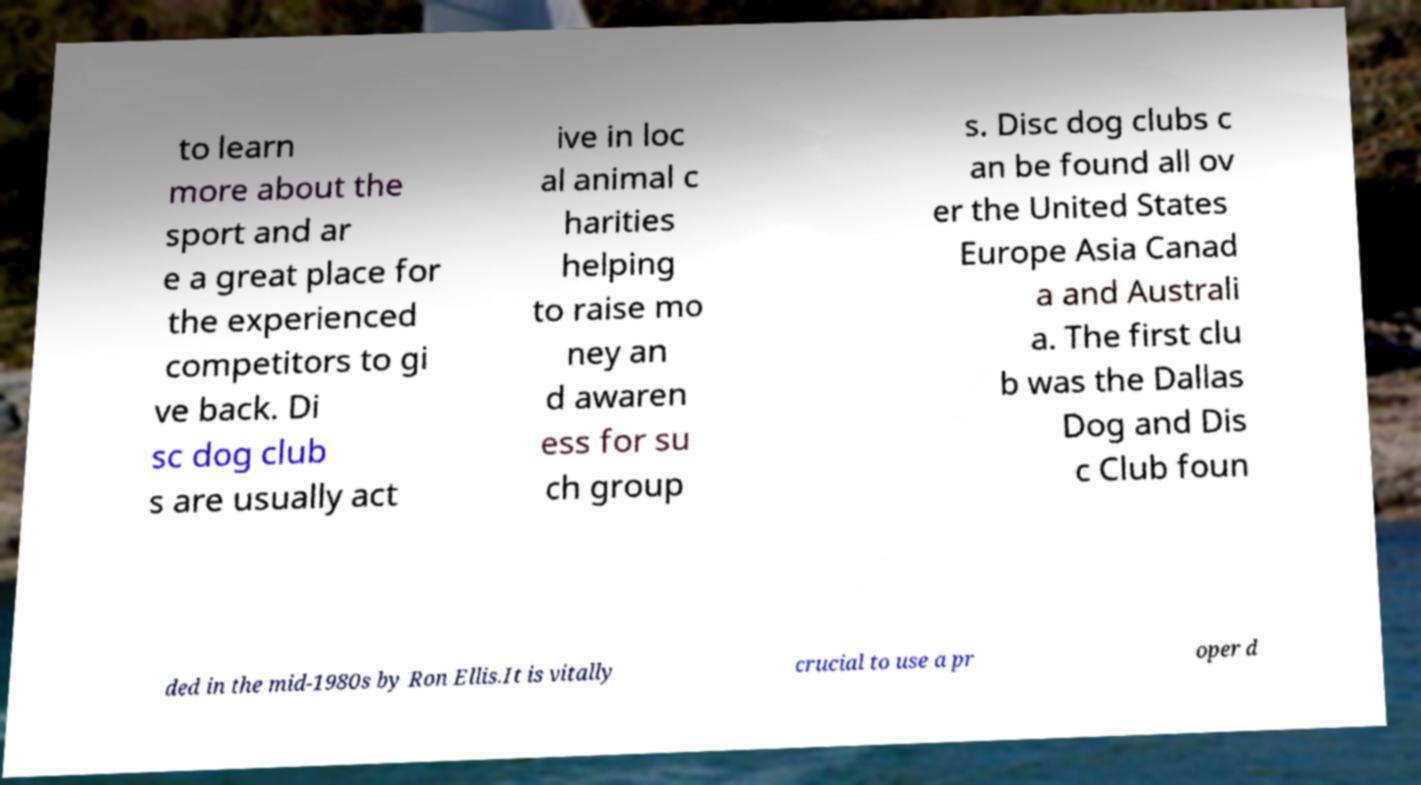Please identify and transcribe the text found in this image. to learn more about the sport and ar e a great place for the experienced competitors to gi ve back. Di sc dog club s are usually act ive in loc al animal c harities helping to raise mo ney an d awaren ess for su ch group s. Disc dog clubs c an be found all ov er the United States Europe Asia Canad a and Australi a. The first clu b was the Dallas Dog and Dis c Club foun ded in the mid-1980s by Ron Ellis.It is vitally crucial to use a pr oper d 